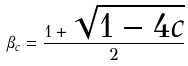Convert formula to latex. <formula><loc_0><loc_0><loc_500><loc_500>\beta _ { c } = \frac { 1 + \sqrt { 1 - 4 c } } { 2 }</formula> 